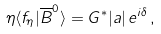<formula> <loc_0><loc_0><loc_500><loc_500>\eta \langle f _ { \eta } | \overline { B } ^ { 0 } \rangle = G ^ { * } | a | \, e ^ { i \delta } \, ,</formula> 